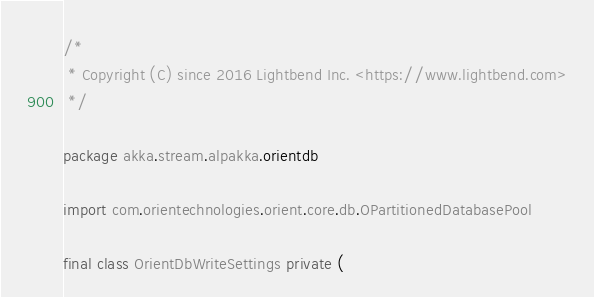Convert code to text. <code><loc_0><loc_0><loc_500><loc_500><_Scala_>/*
 * Copyright (C) since 2016 Lightbend Inc. <https://www.lightbend.com>
 */

package akka.stream.alpakka.orientdb

import com.orientechnologies.orient.core.db.OPartitionedDatabasePool

final class OrientDbWriteSettings private (</code> 